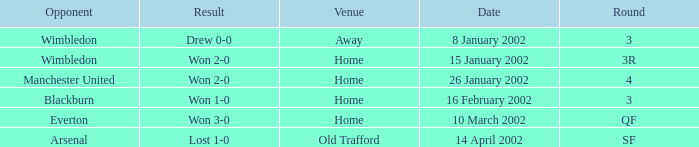What is the Date with a Round with sf? 14 April 2002. 